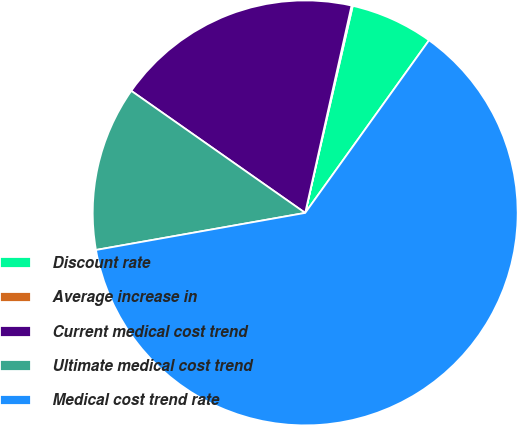Convert chart to OTSL. <chart><loc_0><loc_0><loc_500><loc_500><pie_chart><fcel>Discount rate<fcel>Average increase in<fcel>Current medical cost trend<fcel>Ultimate medical cost trend<fcel>Medical cost trend rate<nl><fcel>6.31%<fcel>0.09%<fcel>18.76%<fcel>12.53%<fcel>62.3%<nl></chart> 